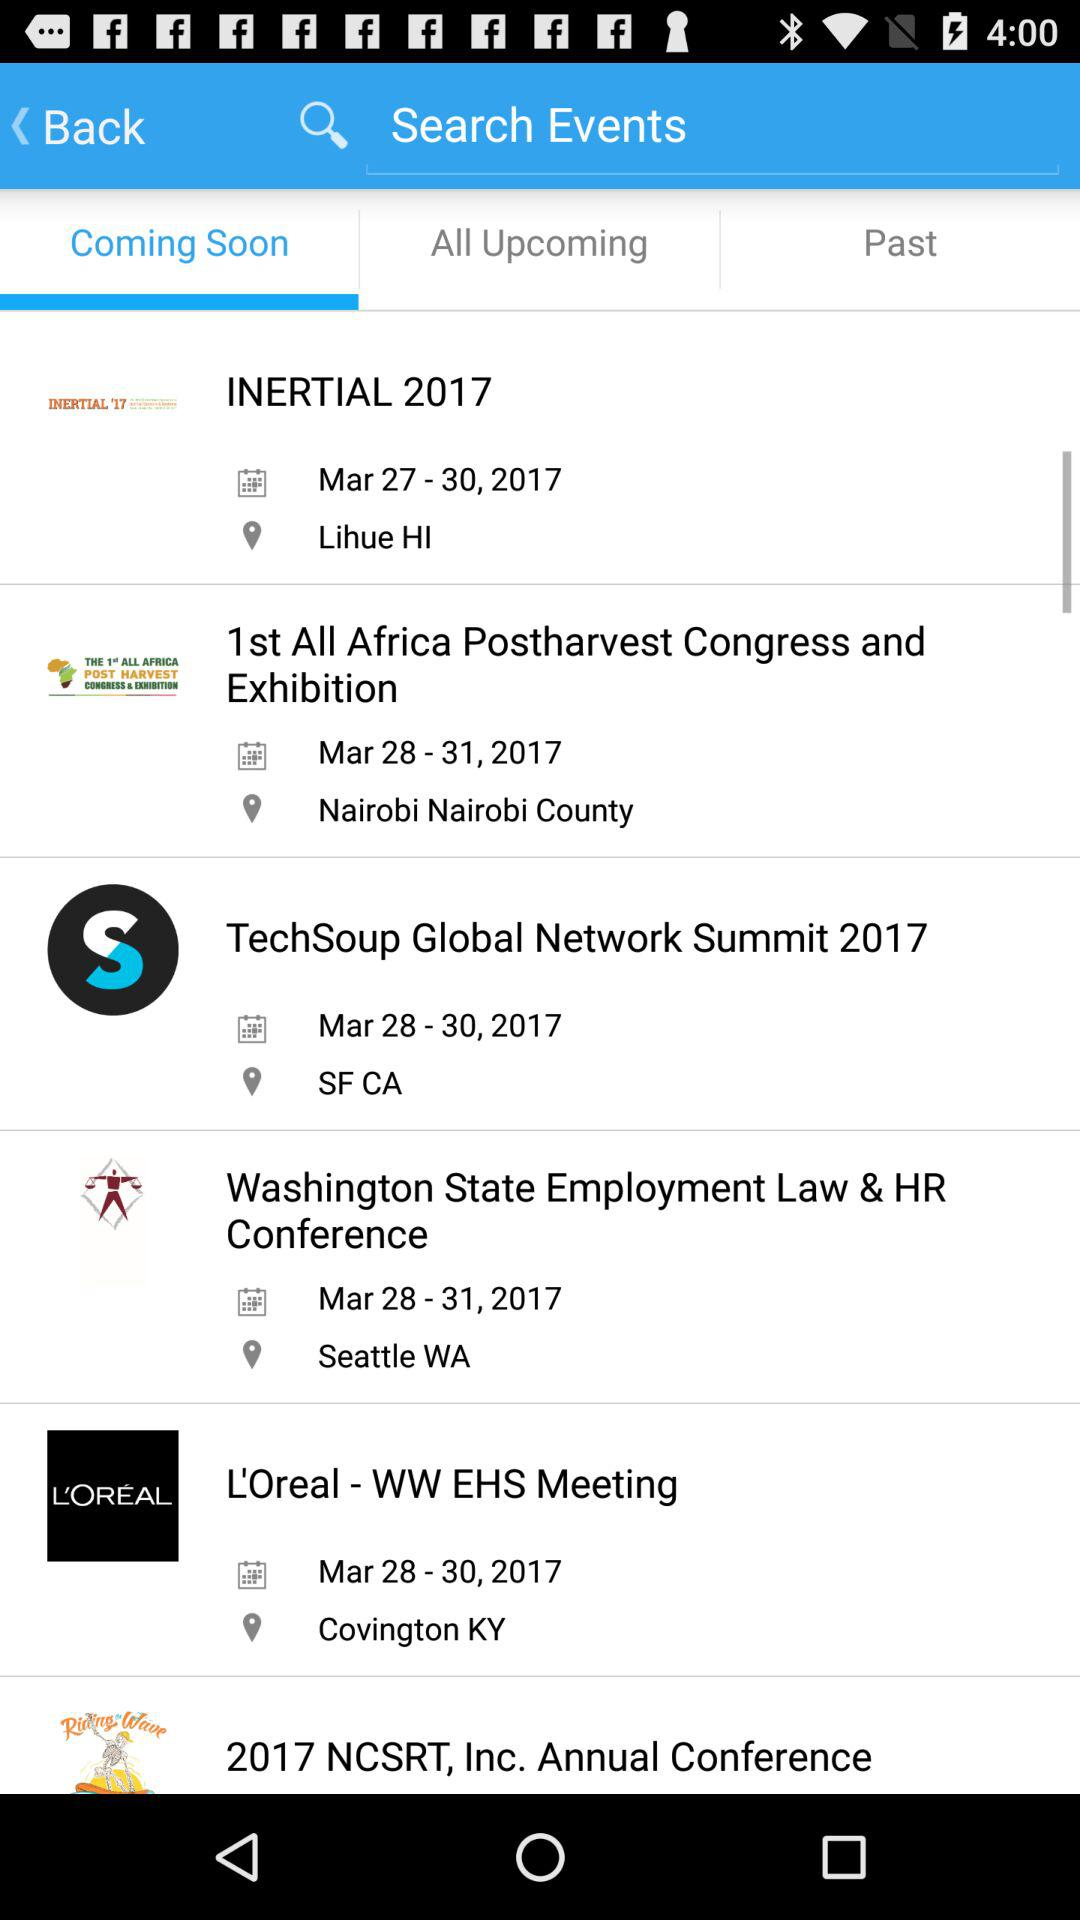Which tab is selected? The selected tab is "Coming Soon". 